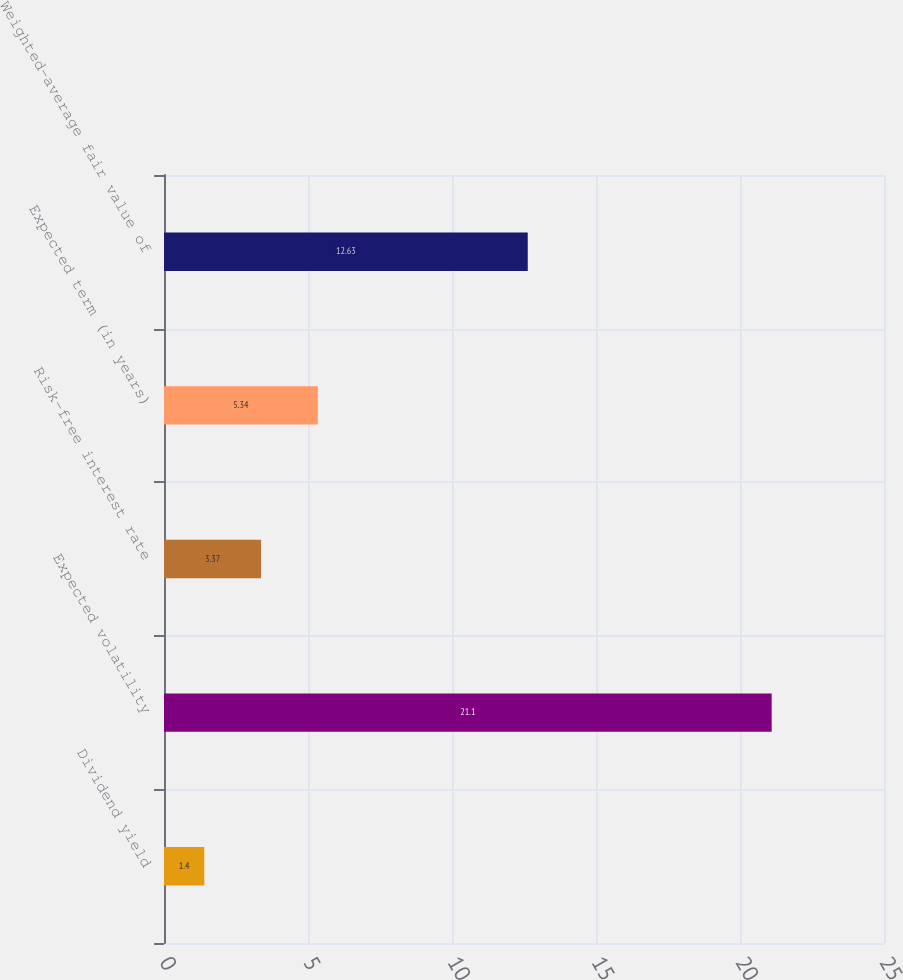Convert chart to OTSL. <chart><loc_0><loc_0><loc_500><loc_500><bar_chart><fcel>Dividend yield<fcel>Expected volatility<fcel>Risk-free interest rate<fcel>Expected term (in years)<fcel>Weighted-average fair value of<nl><fcel>1.4<fcel>21.1<fcel>3.37<fcel>5.34<fcel>12.63<nl></chart> 